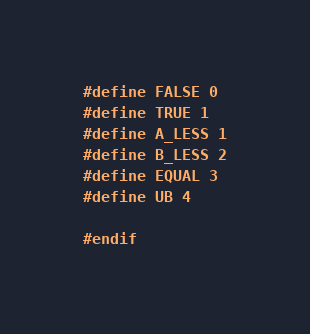Convert code to text. <code><loc_0><loc_0><loc_500><loc_500><_C_>#define FALSE 0
#define TRUE 1
#define A_LESS 1
#define B_LESS 2
#define EQUAL 3
#define UB 4

#endif</code> 